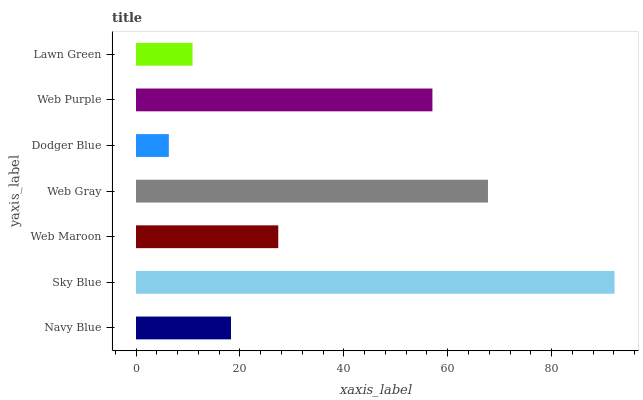Is Dodger Blue the minimum?
Answer yes or no. Yes. Is Sky Blue the maximum?
Answer yes or no. Yes. Is Web Maroon the minimum?
Answer yes or no. No. Is Web Maroon the maximum?
Answer yes or no. No. Is Sky Blue greater than Web Maroon?
Answer yes or no. Yes. Is Web Maroon less than Sky Blue?
Answer yes or no. Yes. Is Web Maroon greater than Sky Blue?
Answer yes or no. No. Is Sky Blue less than Web Maroon?
Answer yes or no. No. Is Web Maroon the high median?
Answer yes or no. Yes. Is Web Maroon the low median?
Answer yes or no. Yes. Is Sky Blue the high median?
Answer yes or no. No. Is Sky Blue the low median?
Answer yes or no. No. 